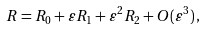<formula> <loc_0><loc_0><loc_500><loc_500>R = R _ { 0 } + \varepsilon R _ { 1 } + \varepsilon ^ { 2 } R _ { 2 } + O ( \varepsilon ^ { 3 } ) \, ,</formula> 